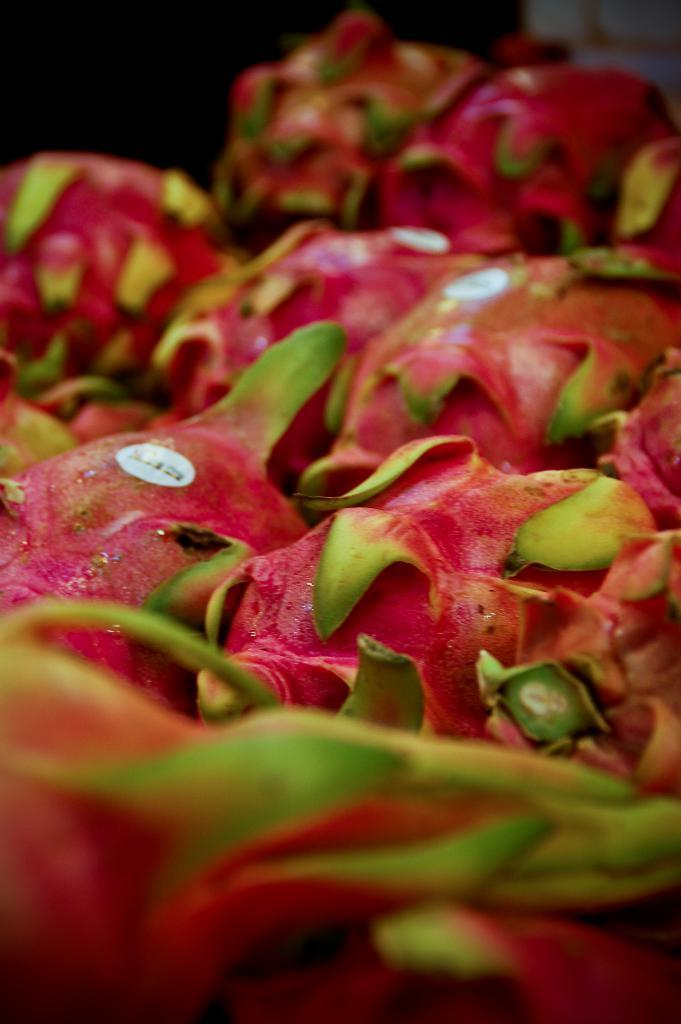What type of objects are present in the image? There are many fruits in the image. Are there any distinguishing features on the fruits? Some fruits have stickers on them. What can be seen in the background of the image? There is a dark background at the top of the image. What type of locket can be seen hanging from the fruits in the image? There is no locket present in the image. 